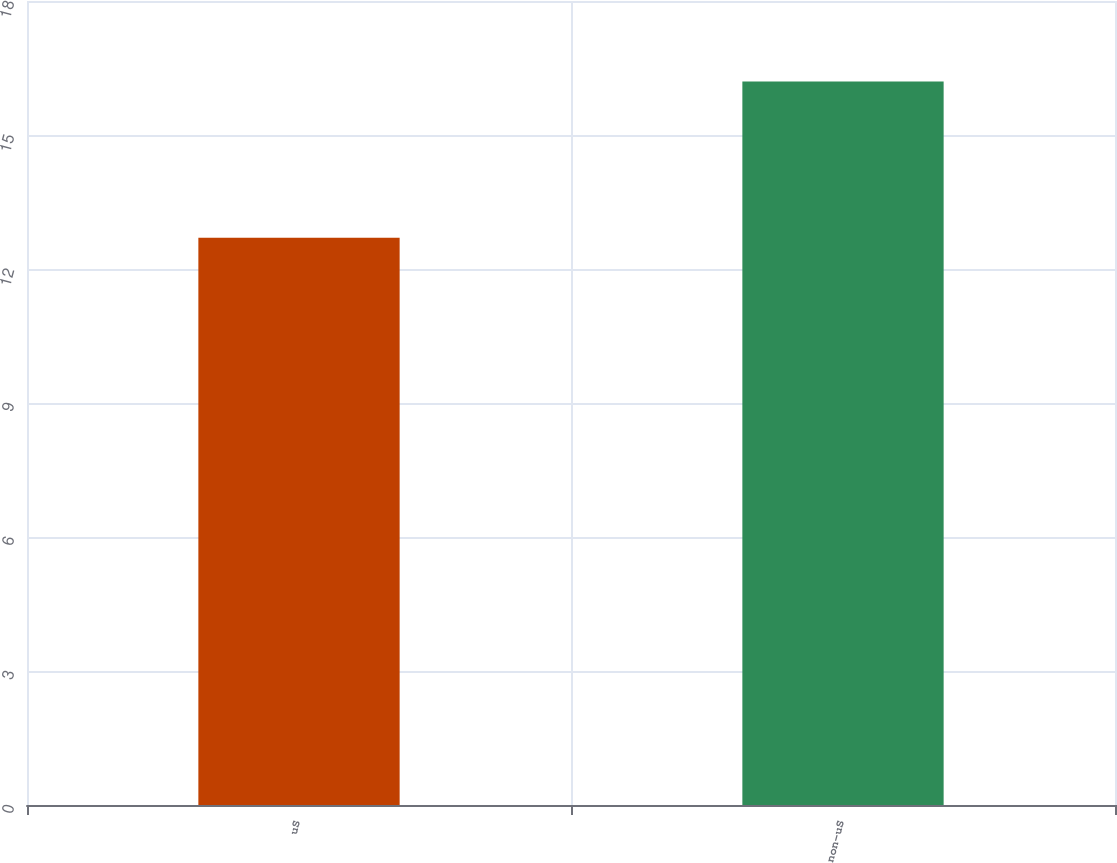<chart> <loc_0><loc_0><loc_500><loc_500><bar_chart><fcel>uS<fcel>non-uS<nl><fcel>12.7<fcel>16.2<nl></chart> 